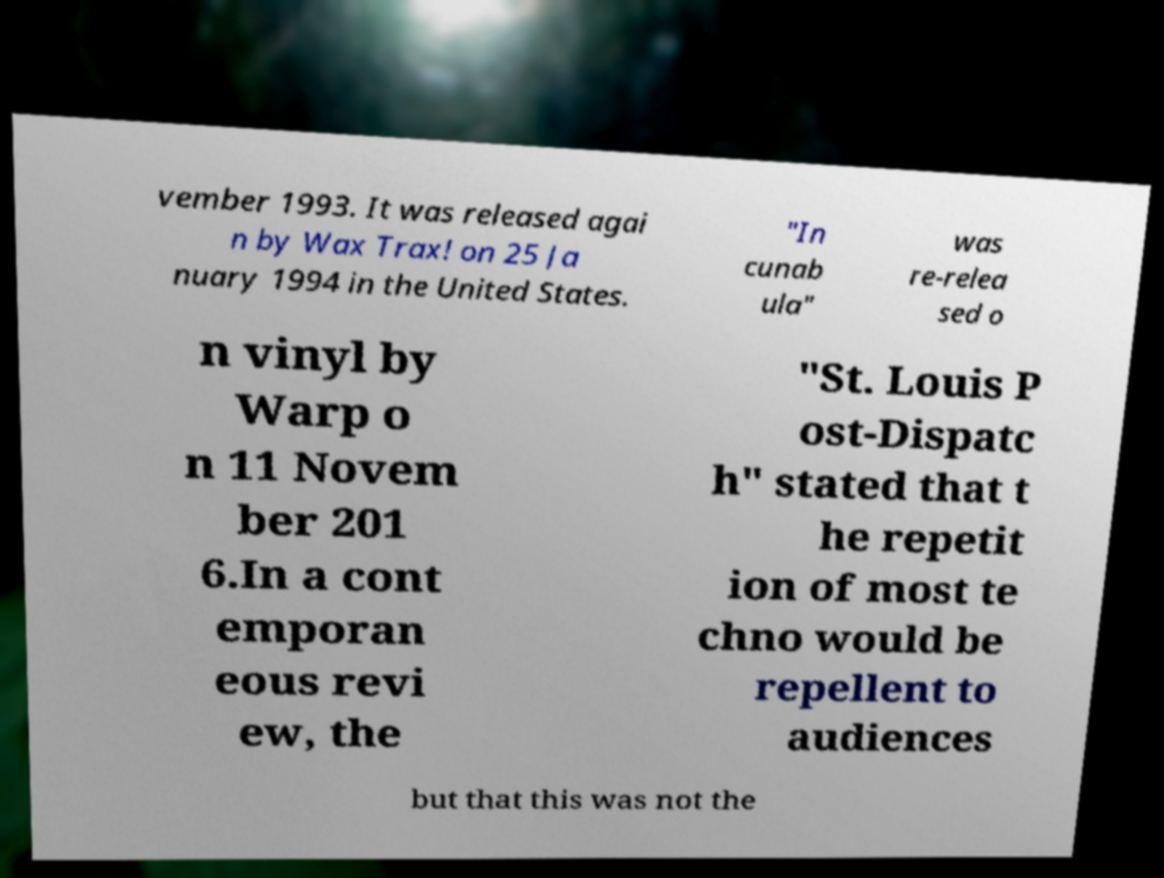Can you accurately transcribe the text from the provided image for me? vember 1993. It was released agai n by Wax Trax! on 25 Ja nuary 1994 in the United States. "In cunab ula" was re-relea sed o n vinyl by Warp o n 11 Novem ber 201 6.In a cont emporan eous revi ew, the "St. Louis P ost-Dispatc h" stated that t he repetit ion of most te chno would be repellent to audiences but that this was not the 